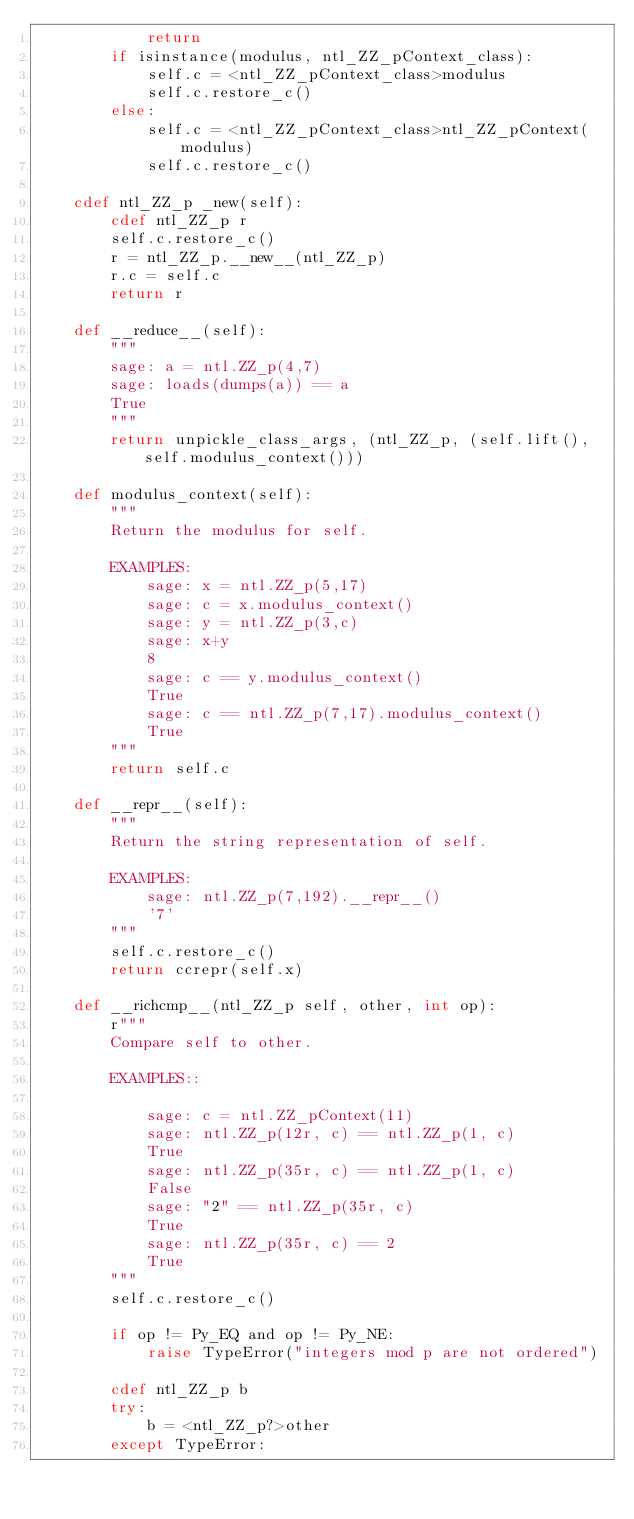Convert code to text. <code><loc_0><loc_0><loc_500><loc_500><_Cython_>            return
        if isinstance(modulus, ntl_ZZ_pContext_class):
            self.c = <ntl_ZZ_pContext_class>modulus
            self.c.restore_c()
        else:
            self.c = <ntl_ZZ_pContext_class>ntl_ZZ_pContext(modulus)
            self.c.restore_c()

    cdef ntl_ZZ_p _new(self):
        cdef ntl_ZZ_p r
        self.c.restore_c()
        r = ntl_ZZ_p.__new__(ntl_ZZ_p)
        r.c = self.c
        return r

    def __reduce__(self):
        """
        sage: a = ntl.ZZ_p(4,7)
        sage: loads(dumps(a)) == a
        True
        """
        return unpickle_class_args, (ntl_ZZ_p, (self.lift(), self.modulus_context()))

    def modulus_context(self):
        """
        Return the modulus for self.

        EXAMPLES:
            sage: x = ntl.ZZ_p(5,17)
            sage: c = x.modulus_context()
            sage: y = ntl.ZZ_p(3,c)
            sage: x+y
            8
            sage: c == y.modulus_context()
            True
            sage: c == ntl.ZZ_p(7,17).modulus_context()
            True
        """
        return self.c

    def __repr__(self):
        """
        Return the string representation of self.

        EXAMPLES:
            sage: ntl.ZZ_p(7,192).__repr__()
            '7'
        """
        self.c.restore_c()
        return ccrepr(self.x)

    def __richcmp__(ntl_ZZ_p self, other, int op):
        r"""
        Compare self to other.

        EXAMPLES::

            sage: c = ntl.ZZ_pContext(11)
            sage: ntl.ZZ_p(12r, c) == ntl.ZZ_p(1, c)
            True
            sage: ntl.ZZ_p(35r, c) == ntl.ZZ_p(1, c)
            False
            sage: "2" == ntl.ZZ_p(35r, c)
            True
            sage: ntl.ZZ_p(35r, c) == 2
            True
        """
        self.c.restore_c()

        if op != Py_EQ and op != Py_NE:
            raise TypeError("integers mod p are not ordered")

        cdef ntl_ZZ_p b
        try:
            b = <ntl_ZZ_p?>other
        except TypeError:</code> 